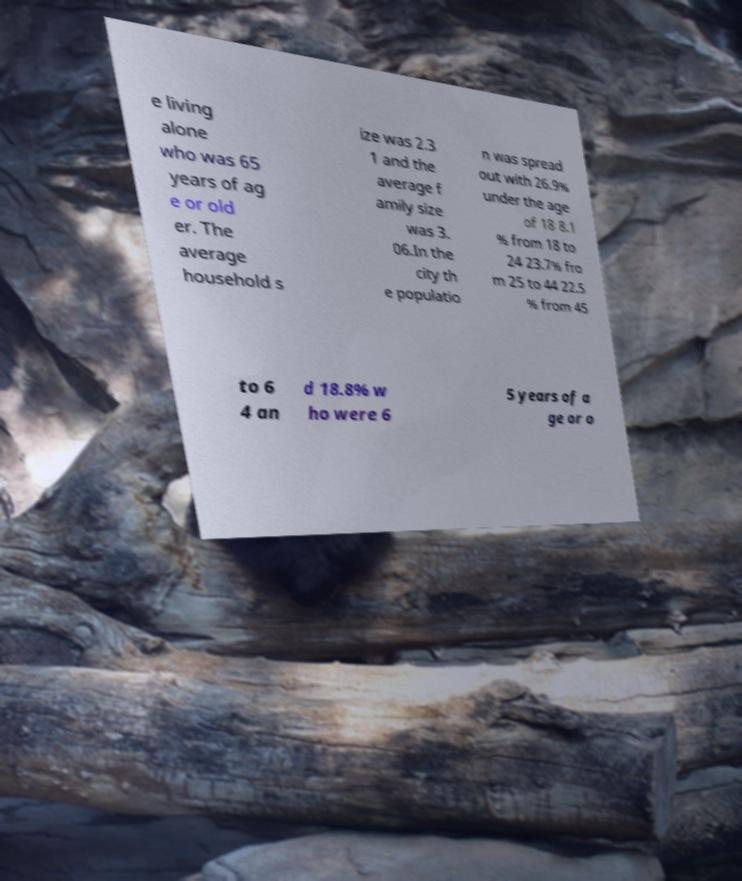What messages or text are displayed in this image? I need them in a readable, typed format. e living alone who was 65 years of ag e or old er. The average household s ize was 2.3 1 and the average f amily size was 3. 06.In the city th e populatio n was spread out with 26.9% under the age of 18 8.1 % from 18 to 24 23.7% fro m 25 to 44 22.5 % from 45 to 6 4 an d 18.8% w ho were 6 5 years of a ge or o 